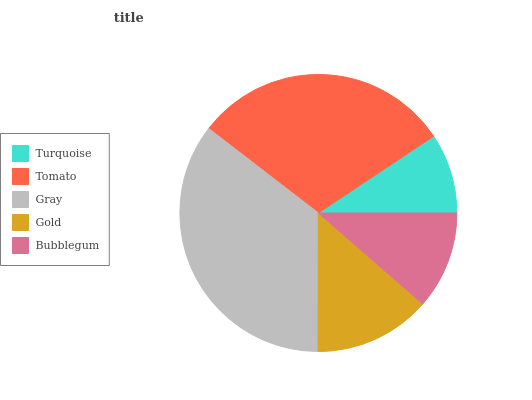Is Turquoise the minimum?
Answer yes or no. Yes. Is Gray the maximum?
Answer yes or no. Yes. Is Tomato the minimum?
Answer yes or no. No. Is Tomato the maximum?
Answer yes or no. No. Is Tomato greater than Turquoise?
Answer yes or no. Yes. Is Turquoise less than Tomato?
Answer yes or no. Yes. Is Turquoise greater than Tomato?
Answer yes or no. No. Is Tomato less than Turquoise?
Answer yes or no. No. Is Gold the high median?
Answer yes or no. Yes. Is Gold the low median?
Answer yes or no. Yes. Is Tomato the high median?
Answer yes or no. No. Is Gray the low median?
Answer yes or no. No. 